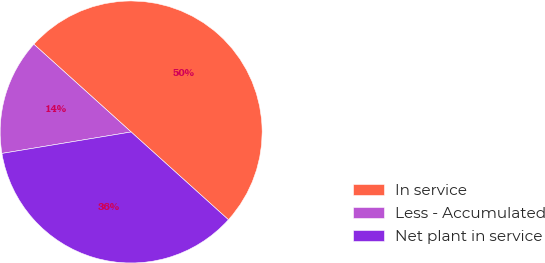Convert chart. <chart><loc_0><loc_0><loc_500><loc_500><pie_chart><fcel>In service<fcel>Less - Accumulated<fcel>Net plant in service<nl><fcel>50.0%<fcel>14.3%<fcel>35.7%<nl></chart> 